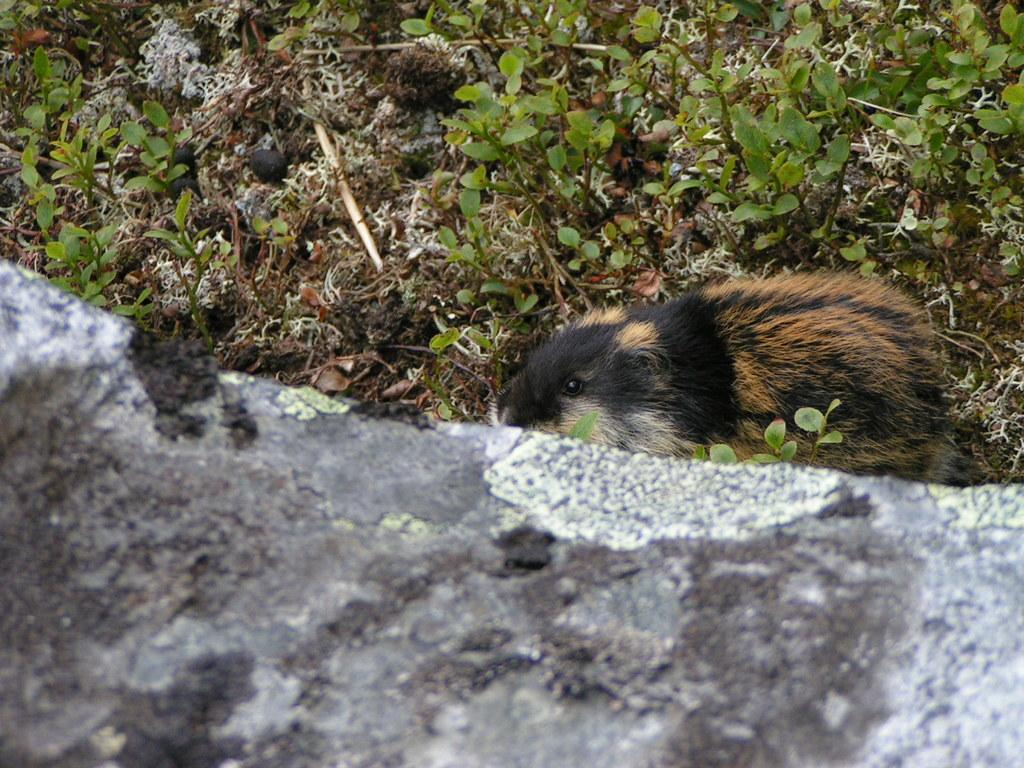What type of animal is in the image? There is an animal in the image, but its specific type is not mentioned in the facts. Where is the animal located in the image? The animal is on the ground in the image. What can be seen in the background of the image? There are planets and stone visible in the background of the image. How many frogs are wearing rings in the image? There is no mention of frogs or rings in the image; it features an animal on the ground with planets and stone visible in the background. Are there any snakes present in the image? There is no mention of snakes in the image; it features an animal on the ground with planets and stone visible in the background. 